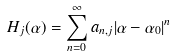Convert formula to latex. <formula><loc_0><loc_0><loc_500><loc_500>H _ { j } ( \alpha ) = \sum _ { n = 0 } ^ { \infty } a _ { n , j } | \alpha - \alpha _ { 0 } | ^ { n }</formula> 